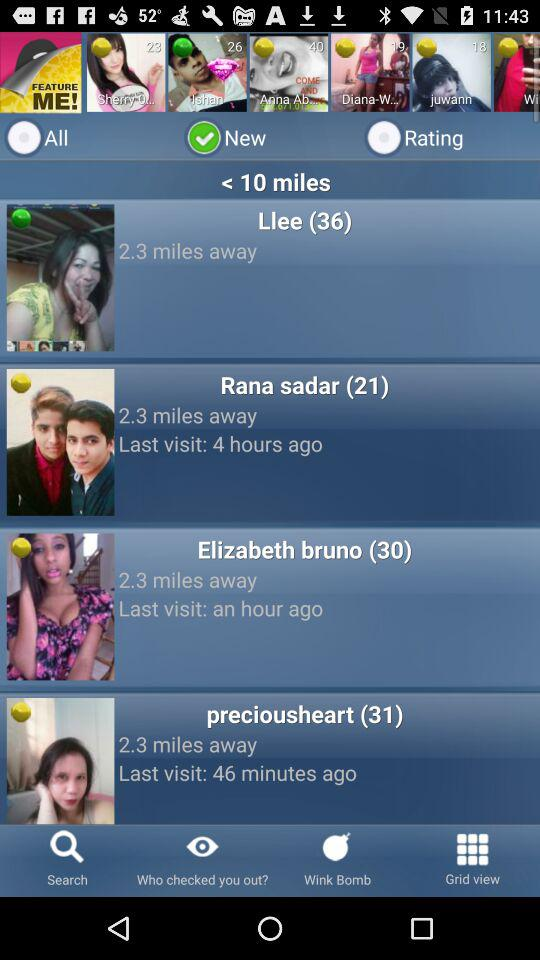When did "Llee" last visit?
When the provided information is insufficient, respond with <no answer>. <no answer> 